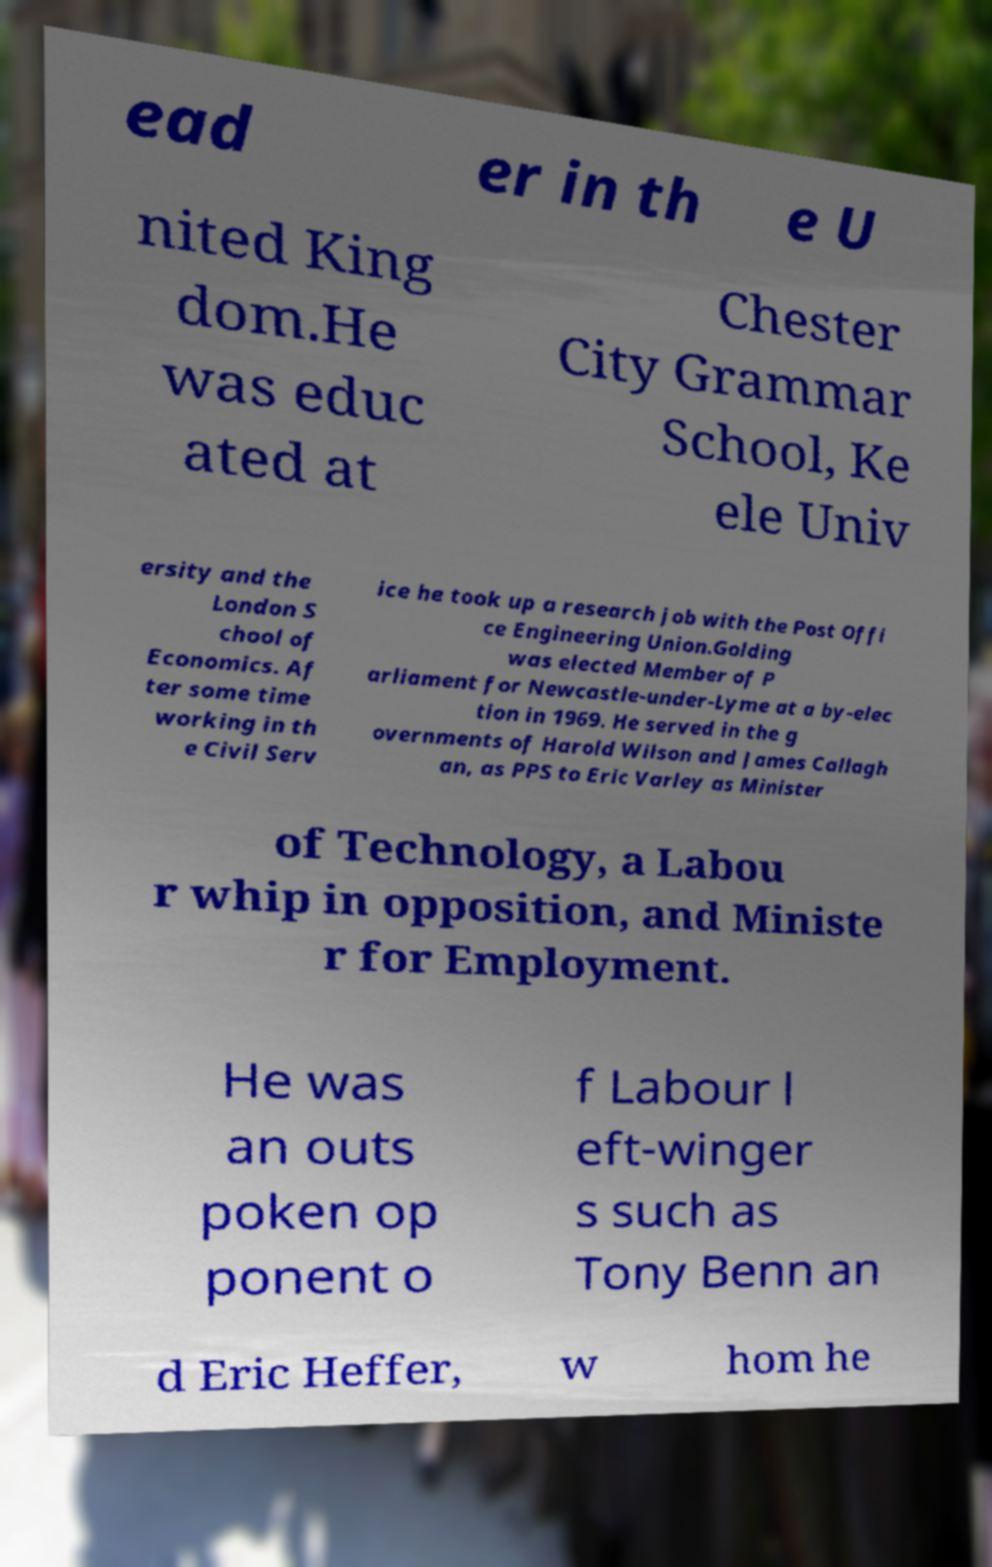I need the written content from this picture converted into text. Can you do that? ead er in th e U nited King dom.He was educ ated at Chester City Grammar School, Ke ele Univ ersity and the London S chool of Economics. Af ter some time working in th e Civil Serv ice he took up a research job with the Post Offi ce Engineering Union.Golding was elected Member of P arliament for Newcastle-under-Lyme at a by-elec tion in 1969. He served in the g overnments of Harold Wilson and James Callagh an, as PPS to Eric Varley as Minister of Technology, a Labou r whip in opposition, and Ministe r for Employment. He was an outs poken op ponent o f Labour l eft-winger s such as Tony Benn an d Eric Heffer, w hom he 